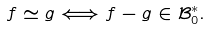<formula> <loc_0><loc_0><loc_500><loc_500>f \simeq g \Longleftrightarrow f - g \in \mathcal { B } ^ { \ast } _ { 0 } .</formula> 